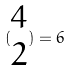<formula> <loc_0><loc_0><loc_500><loc_500>( \begin{matrix} 4 \\ 2 \end{matrix} ) = 6</formula> 